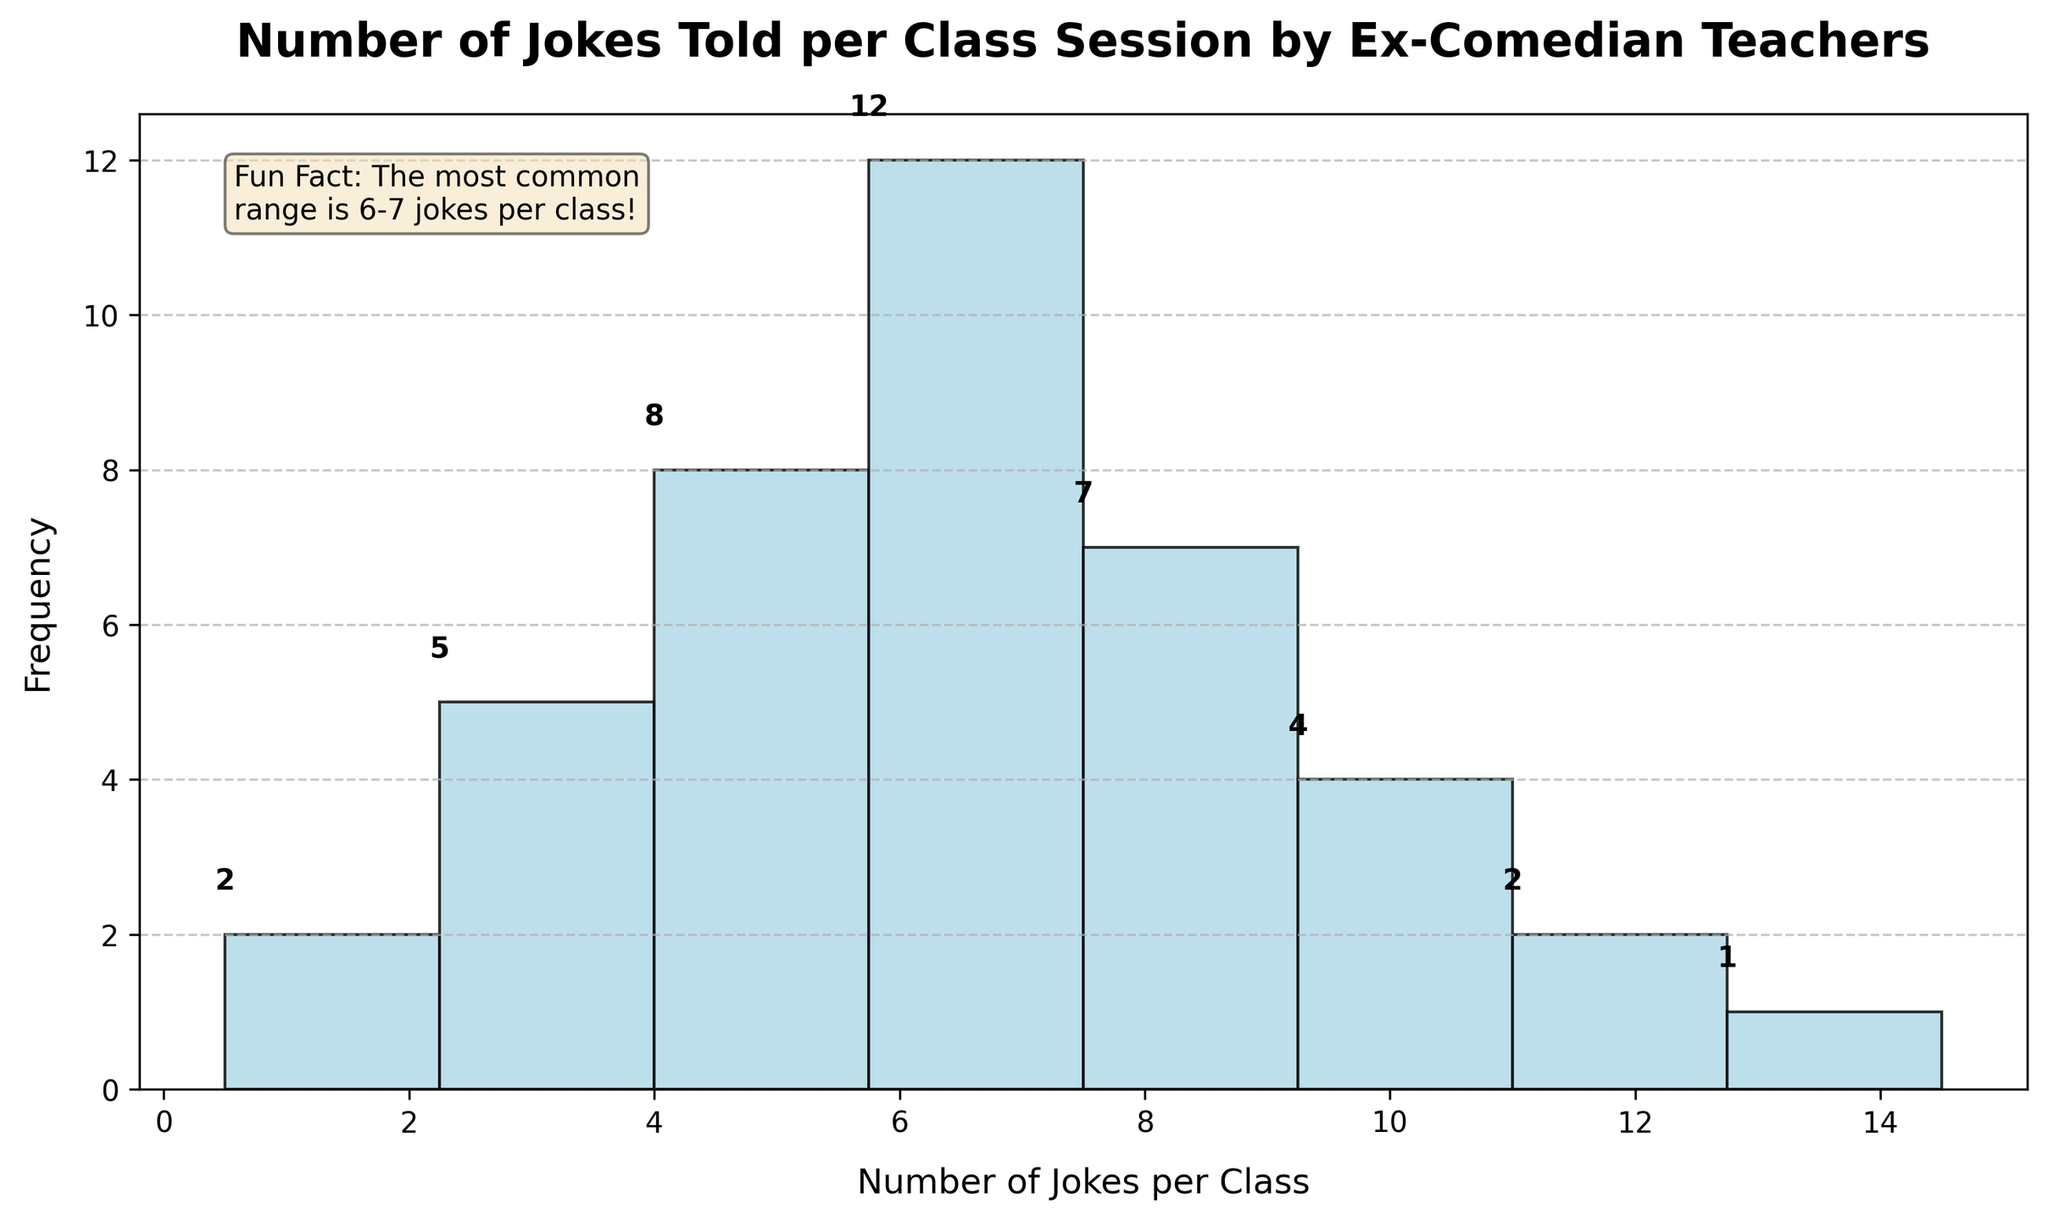What is the title of the histogram? The title is written at the top of the figure. The text is bold and large to capture attention.
Answer: Number of Jokes Told per Class Session by Ex-Comedian Teachers What is the range with the highest frequency of jokes per class session? The histogram bar representing the 6-7 jokes range is the tallest. The frequency label above this bar shows it has the highest count.
Answer: 6-7 How many class sessions had 2-3 jokes? The bar corresponding to the 2-3 range has a label showing the frequency. This label is above the relevant bar.
Answer: 5 What is the total number of class sessions recorded in this histogram? Add the frequencies of all the bars: 2 (0-1) + 5 (2-3) + 8 (4-5) + 12 (6-7) + 7 (8-9) + 4 (10-11) + 2 (12-13) + 1 (14-15).
Answer: 41 Which range has the lowest frequency? The bar heights indicate frequency. The 14-15 range bar is the shortest, and the label confirms it.
Answer: 14-15 How many class sessions had at least 8 jokes? Add the frequencies for the bars covering 8-9, 10-11, 12-13, and 14-15 ranges. 7 (8-9) + 4 (10-11) + 2 (12-13) + 1 (14-15).
Answer: 14 What is the fun fact mentioned in the figure? There is a text box on the figure with a "Fun Fact" label. It highlights the most common range of jokes.
Answer: The most common range is 6-7 jokes per class How does the frequency of the range 4-5 jokes compare to the range 10-11 jokes? Compare the bar heights and the frequency labels. The 4-5 range has 8, while the 10-11 range has 4.
Answer: 4-5 is higher What is the frequency of jokes in the range 0-1? Check the label above the bar representing the 0-1 range.
Answer: 2 What is the average number of jokes told per class session across all ranges? Sum the products of midpoints and frequencies, divide by the total number of sessions: (2*0.5 + 5*2.5 + 8*4.5 + 12*6.5 + 7*8.5 + 4*10.5 + 2*12.5 + 1*14.5) / 41. Detailed steps:
(1) (2*0.5 = 1)
(2) (5*2.5 = 12.5)
(3) (8*4.5 = 36)
(4) (12*6.5 = 78)
(5) (7*8.5 = 59.5)
(6) (4*10.5 = 42)
(7) (2*12.5 = 25)
(8) (1*14.5 = 14.5)
Add these products: 1 + 12.5 + 36 + 78 + 59.5 + 42 + 25 + 14.5 = 268.5
Divide by total sessions: 268.5 / 41 = 6.5
Answer: 6.5 